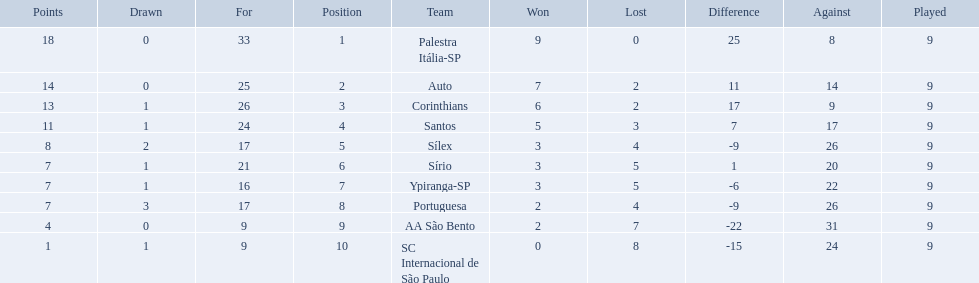What are all the teams? Palestra Itália-SP, Auto, Corinthians, Santos, Sílex, Sírio, Ypiranga-SP, Portuguesa, AA São Bento, SC Internacional de São Paulo. How many times did each team lose? 0, 2, 2, 3, 4, 5, 5, 4, 7, 8. And which team never lost? Palestra Itália-SP. 